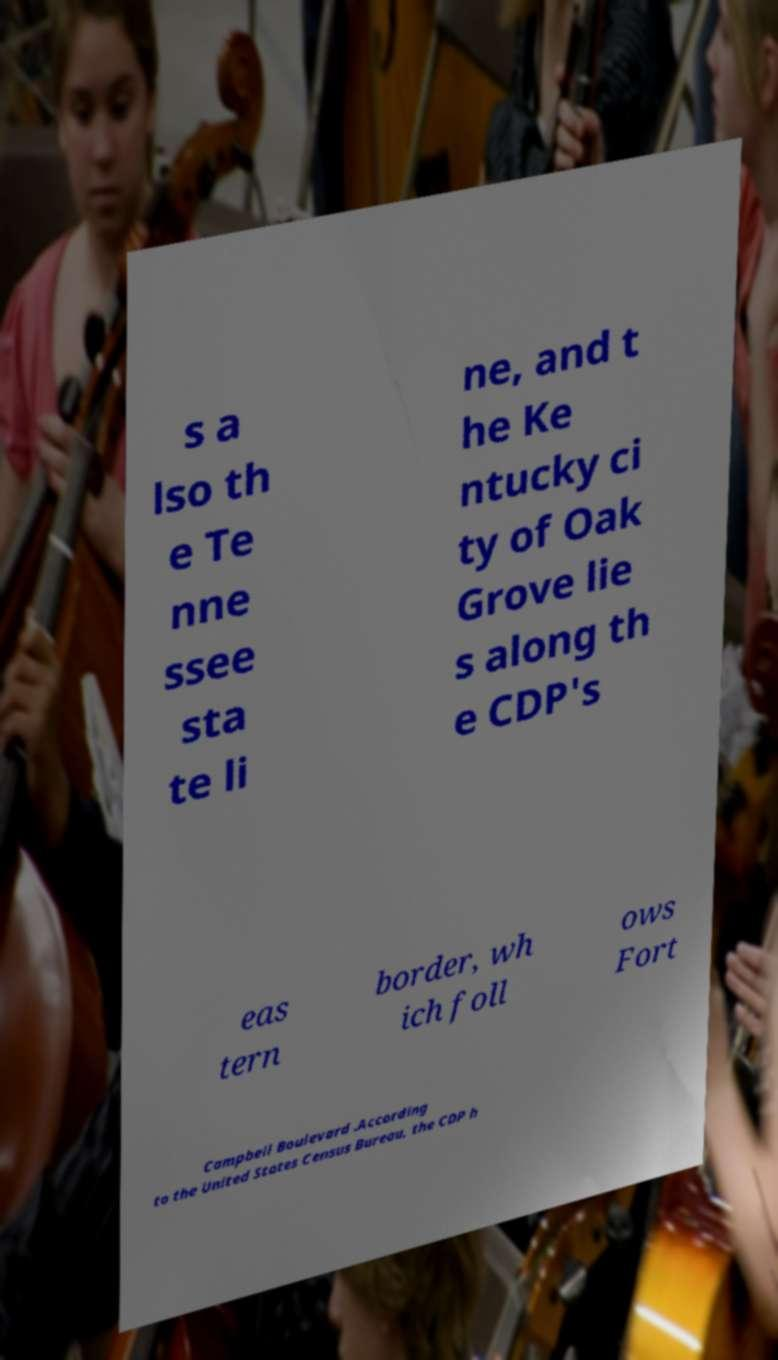Please identify and transcribe the text found in this image. s a lso th e Te nne ssee sta te li ne, and t he Ke ntucky ci ty of Oak Grove lie s along th e CDP's eas tern border, wh ich foll ows Fort Campbell Boulevard .According to the United States Census Bureau, the CDP h 